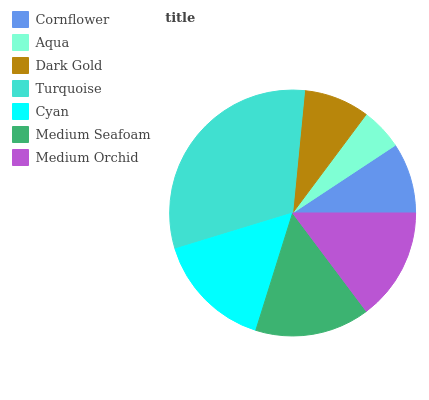Is Aqua the minimum?
Answer yes or no. Yes. Is Turquoise the maximum?
Answer yes or no. Yes. Is Dark Gold the minimum?
Answer yes or no. No. Is Dark Gold the maximum?
Answer yes or no. No. Is Dark Gold greater than Aqua?
Answer yes or no. Yes. Is Aqua less than Dark Gold?
Answer yes or no. Yes. Is Aqua greater than Dark Gold?
Answer yes or no. No. Is Dark Gold less than Aqua?
Answer yes or no. No. Is Medium Orchid the high median?
Answer yes or no. Yes. Is Medium Orchid the low median?
Answer yes or no. Yes. Is Dark Gold the high median?
Answer yes or no. No. Is Dark Gold the low median?
Answer yes or no. No. 